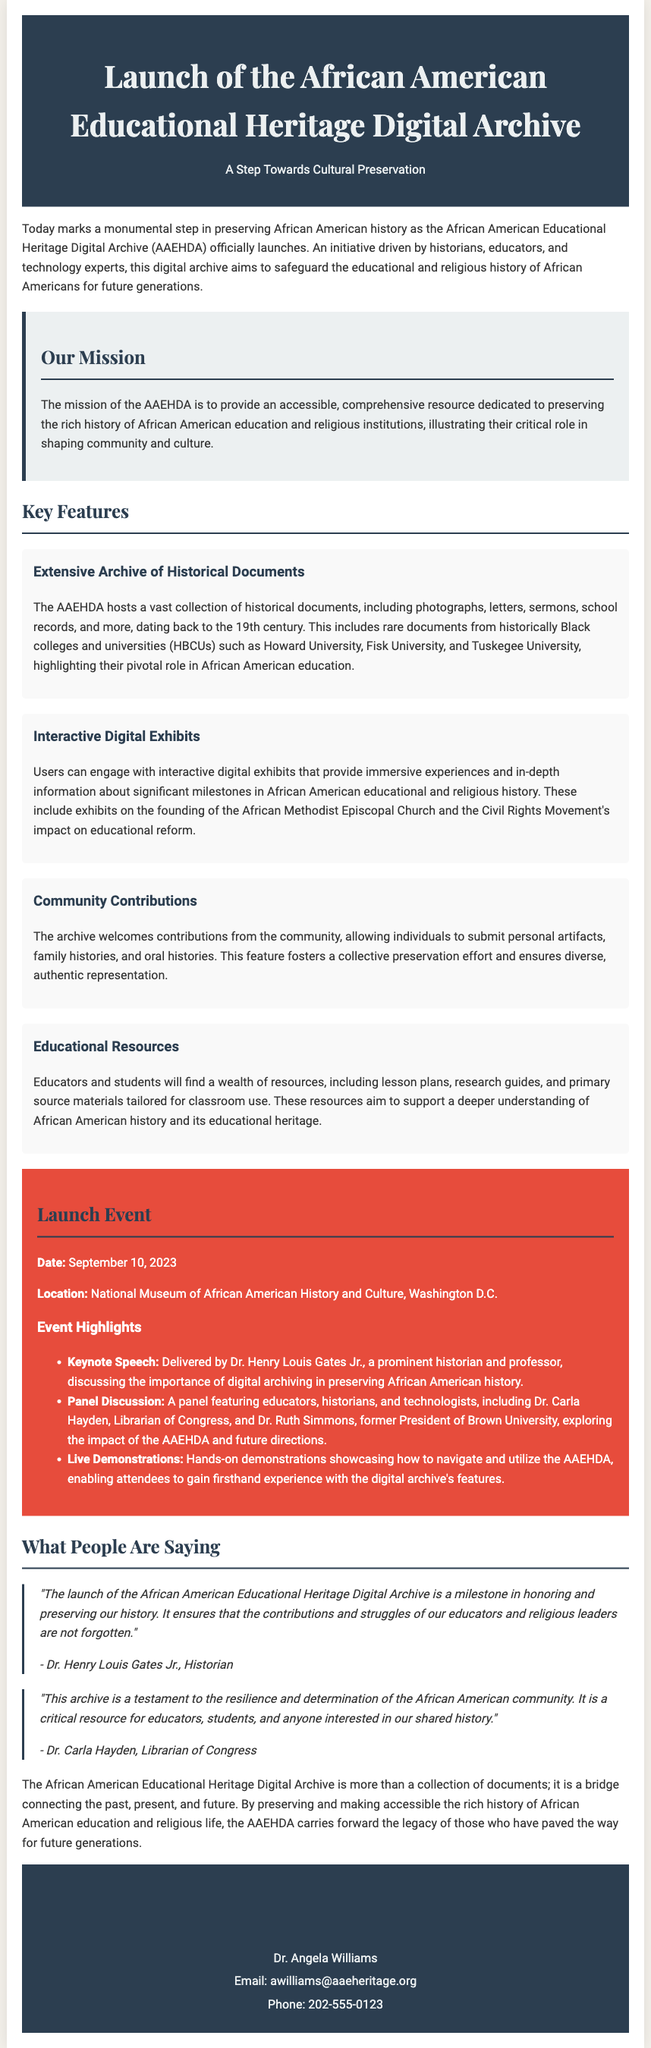What is the date of the launch event? The date of the launch event is mentioned in the "Launch Event" section of the document.
Answer: September 10, 2023 Who delivered the keynote speech? The keynote speech was delivered by Dr. Henry Louis Gates Jr., as noted in the event highlights.
Answer: Dr. Henry Louis Gates Jr What is the main mission of the AAEHDA? The mission of the AAEHDA is outlined in the "Our Mission" section, describing the preservation of African American educational and religious history.
Answer: To provide an accessible, comprehensive resource dedicated to preserving the rich history of African American education and religious institutions What type of contributions does the archive welcome? The document mentions community contributions in the "Community Contributions" feature.
Answer: Personal artifacts, family histories, and oral histories Which three HBCUs are mentioned in the document? The names of HBCUs included are in the "Extensive Archive of Historical Documents" feature.
Answer: Howard University, Fisk University, and Tuskegee University What is highlighted as the role of educational resources in the AAEHDA? The document specifies the purpose of the educational resources in the "Educational Resources" feature.
Answer: Support a deeper understanding of African American history What is a key aspect of the interactive digital exhibits? The key aspect is described in the "Interactive Digital Exhibits" feature.
Answer: Immersive experiences and in-depth information What do both Dr. Henry Louis Gates Jr. and Dr. Carla Hayden commend about the AAEHDA? The quotes in the "What People Are Saying" section emphasize their views on the importance of the archive.
Answer: Preserving history 